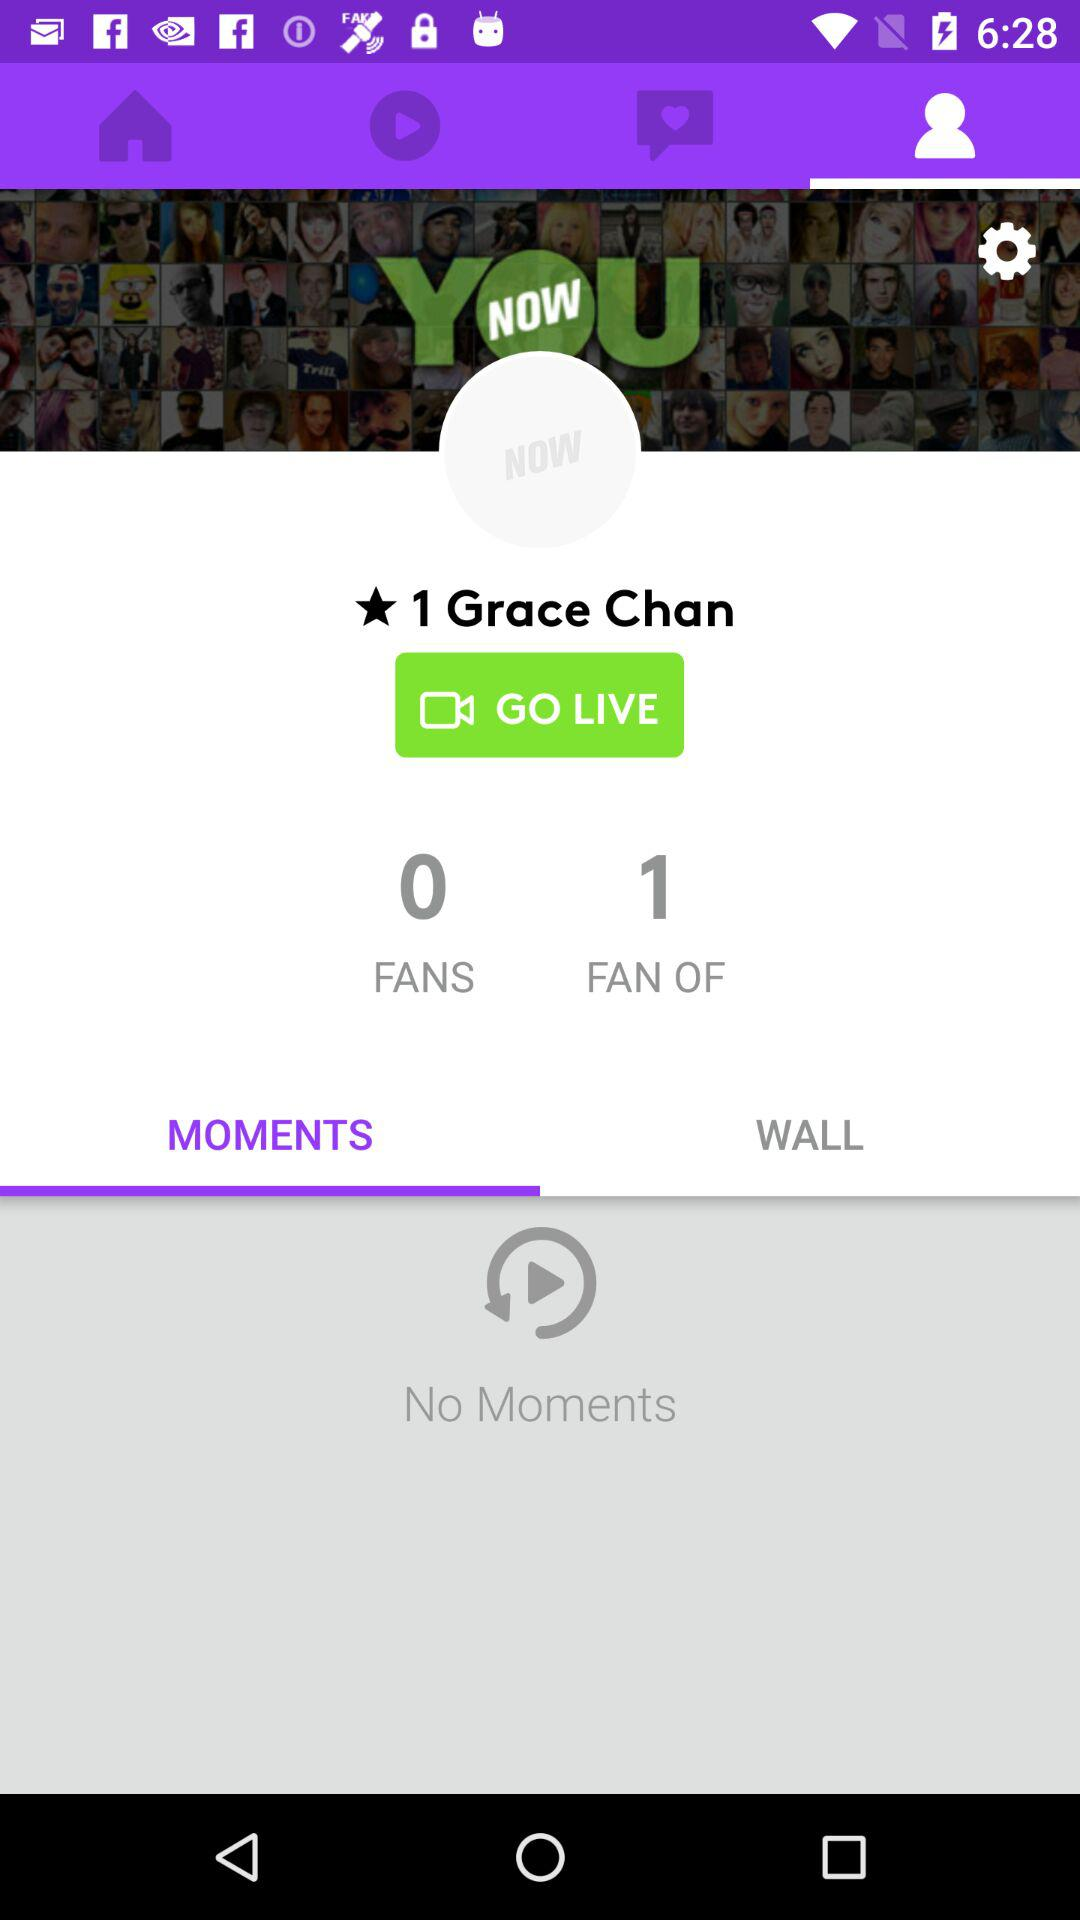Which tab is selected? The selected tabs are "Profile" and "MOMENTS". 